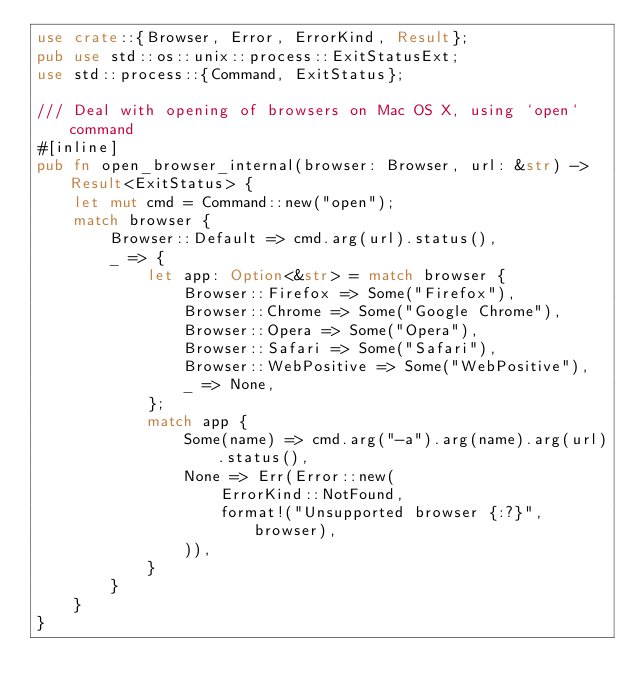Convert code to text. <code><loc_0><loc_0><loc_500><loc_500><_Rust_>use crate::{Browser, Error, ErrorKind, Result};
pub use std::os::unix::process::ExitStatusExt;
use std::process::{Command, ExitStatus};

/// Deal with opening of browsers on Mac OS X, using `open` command
#[inline]
pub fn open_browser_internal(browser: Browser, url: &str) -> Result<ExitStatus> {
    let mut cmd = Command::new("open");
    match browser {
        Browser::Default => cmd.arg(url).status(),
        _ => {
            let app: Option<&str> = match browser {
                Browser::Firefox => Some("Firefox"),
                Browser::Chrome => Some("Google Chrome"),
                Browser::Opera => Some("Opera"),
                Browser::Safari => Some("Safari"),
                Browser::WebPositive => Some("WebPositive"),
                _ => None,
            };
            match app {
                Some(name) => cmd.arg("-a").arg(name).arg(url).status(),
                None => Err(Error::new(
                    ErrorKind::NotFound,
                    format!("Unsupported browser {:?}", browser),
                )),
            }
        }
    }
}
</code> 